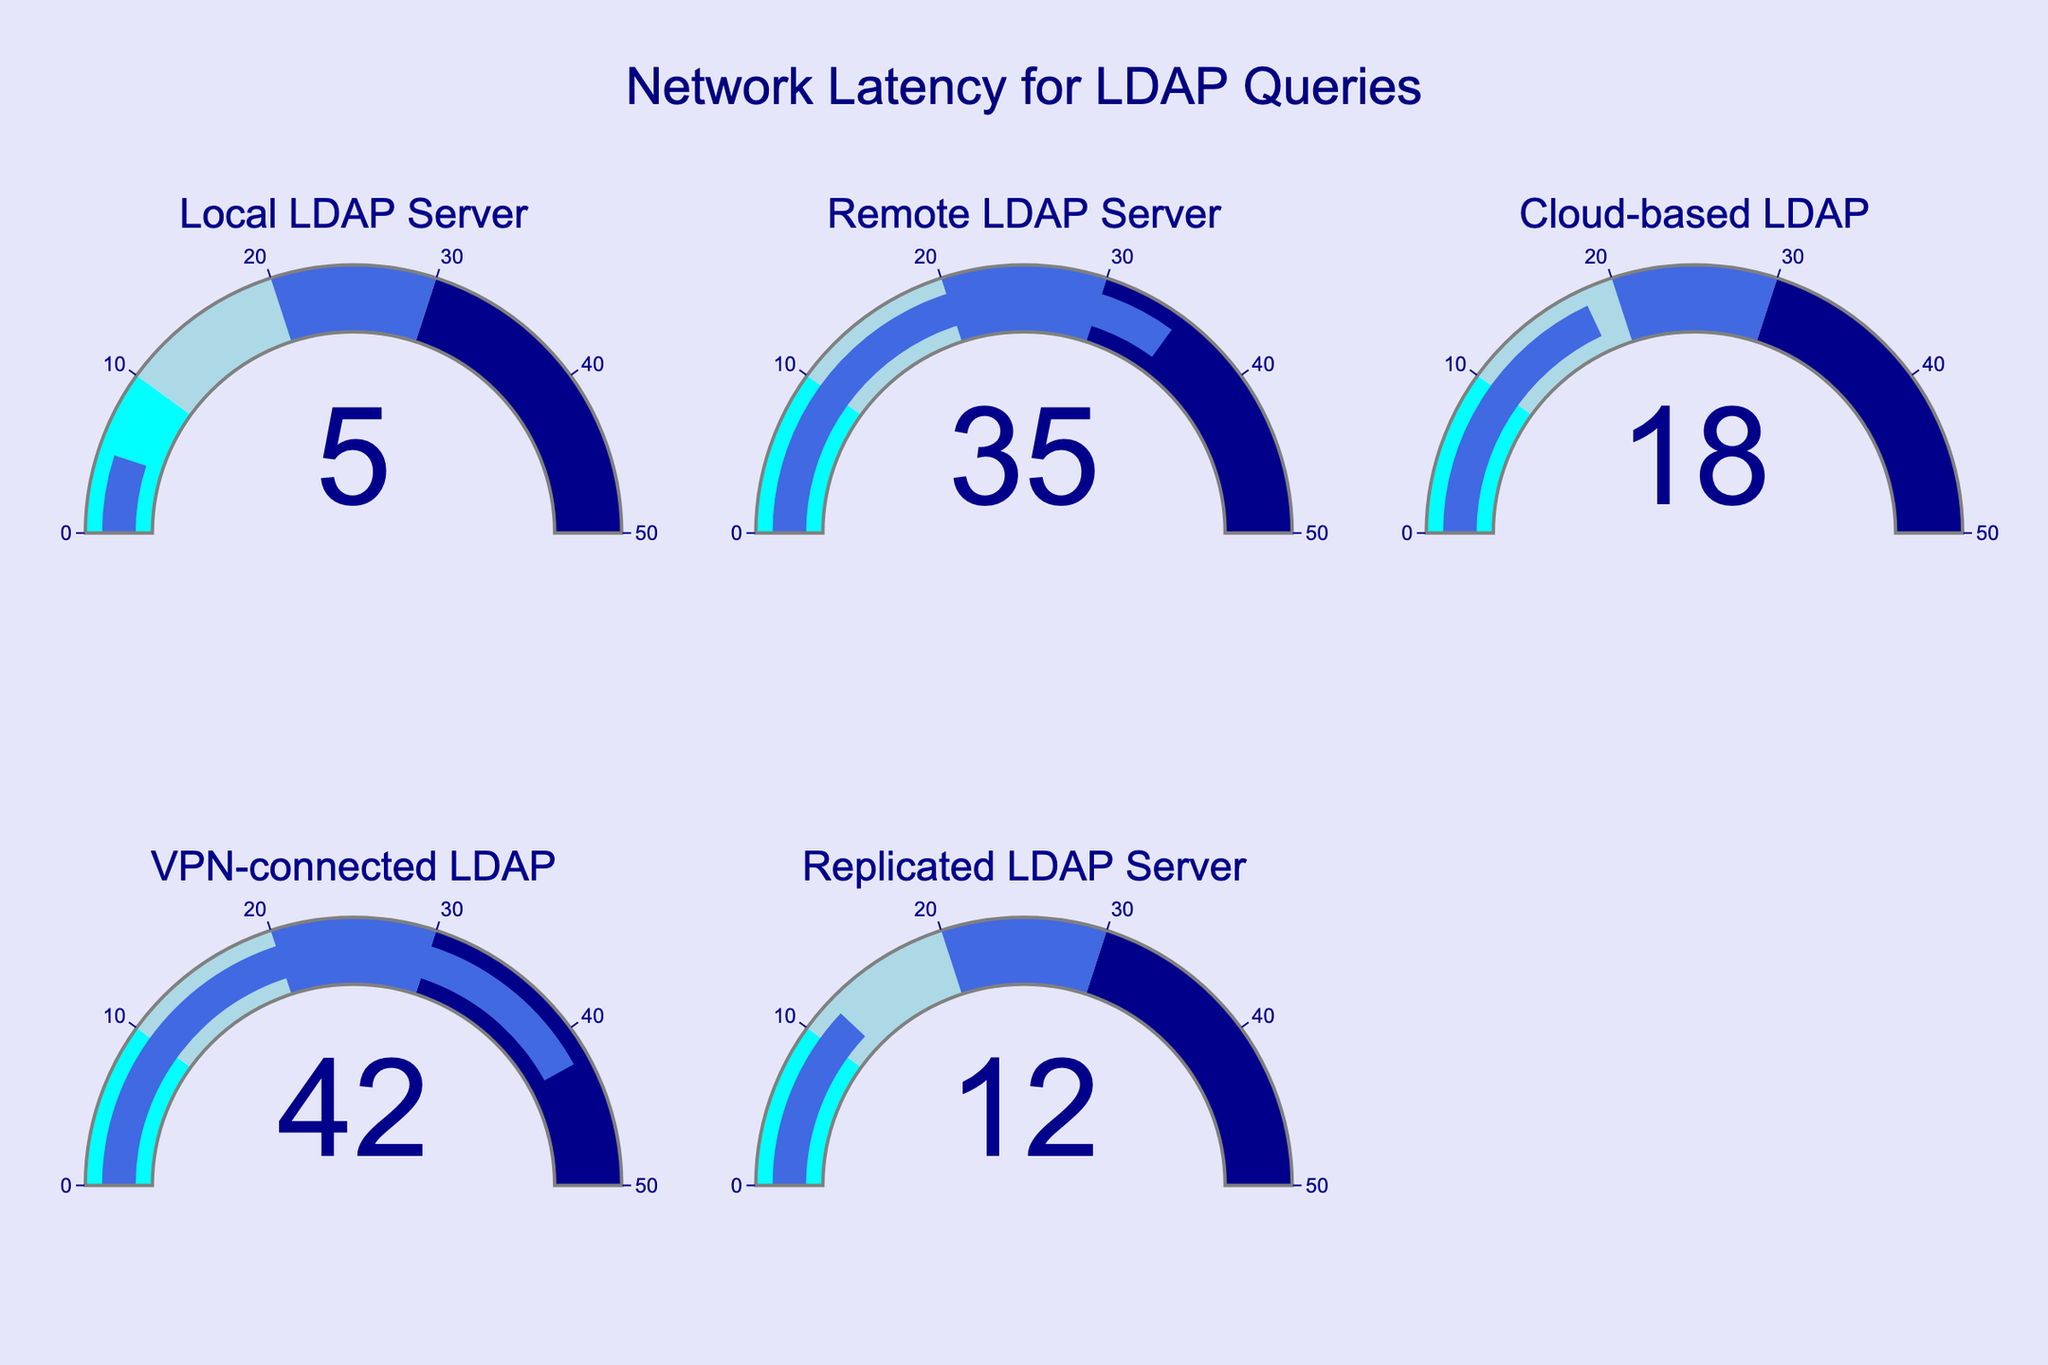What's the highest network latency displayed in the figure? Identify each data point and compare their latency values. The highest latency is 42 milliseconds for the VPN-connected LDAP.
Answer: 42 milliseconds What is the title of the figure? The title is displayed at the top center of the figure. The title is "Network Latency for LDAP Queries".
Answer: Network Latency for LDAP Queries What is the average network latency of the displayed LDAP servers? The latencies are 5, 35, 18, 42, and 12 milliseconds. Summing these gives 112. Dividing by the number of data points (5), we get an average of 22.4.
Answer: 22.4 milliseconds Which LDAP server has the lowest latency? Compare all the network latency values; the lowest value is 5 milliseconds for the Local LDAP Server.
Answer: Local LDAP Server How many LDAP servers are displayed in the figure? Count the number of unique gauges presented in the figure. There are 5 LDAP servers displayed.
Answer: 5 What color represents latency values between 10 to 20 milliseconds on the gauges? Examine the color coding for latency ranges on the gauges. The color for the range 10 to 20 milliseconds is light blue.
Answer: Light blue What is the range of latency represented on the gauge indicators? Check the axis range indicated for each gauge. The range is from 0 to 50 milliseconds.
Answer: 0 to 50 milliseconds How much higher is the latency of the VPN-connected LDAP compared to the Cloud-based LDAP? Subtract the latency of the Cloud-based LDAP (18 milliseconds) from the VPN-connected LDAP (42 milliseconds). The difference is 24 milliseconds.
Answer: 24 milliseconds 